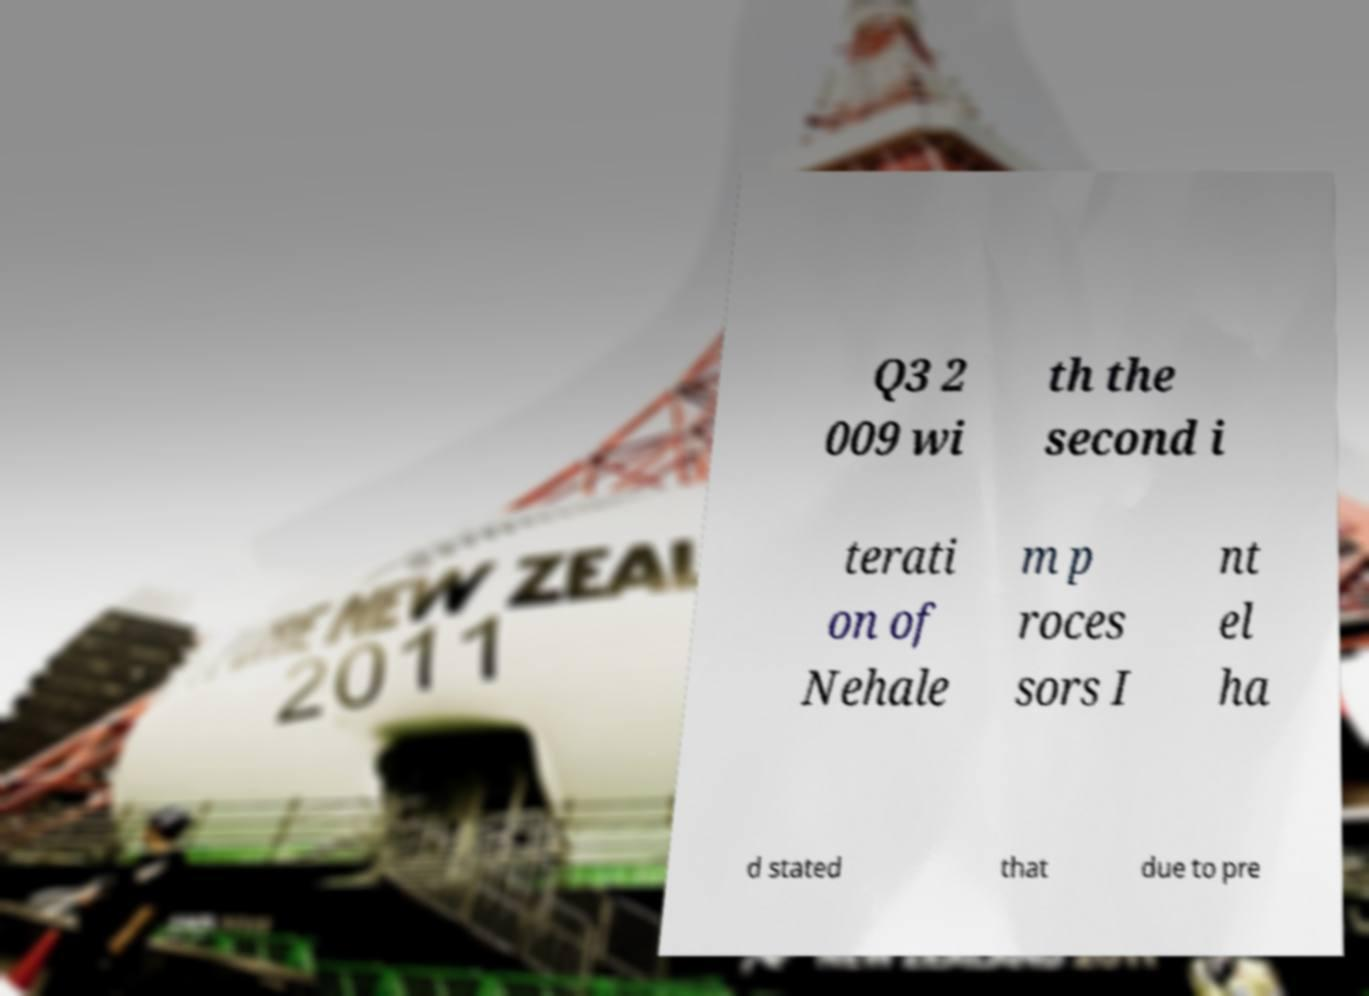Please identify and transcribe the text found in this image. Q3 2 009 wi th the second i terati on of Nehale m p roces sors I nt el ha d stated that due to pre 